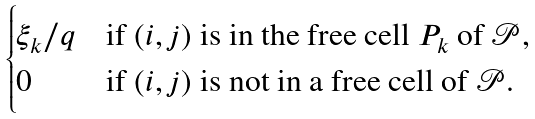Convert formula to latex. <formula><loc_0><loc_0><loc_500><loc_500>\begin{cases} \xi _ { k } / q & \text {if $(i,j)$ is in the free cell $P_{k}$ of $\mathscr{P}$,} \\ 0 & \text {if $(i,j)$ is not in a free cell of $\mathscr{P}$.} \end{cases}</formula> 